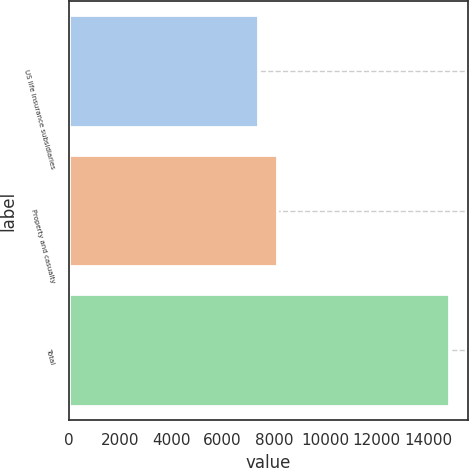<chart> <loc_0><loc_0><loc_500><loc_500><bar_chart><fcel>US life insurance subsidiaries<fcel>Property and casualty<fcel>Total<nl><fcel>7388<fcel>8129.2<fcel>14800<nl></chart> 